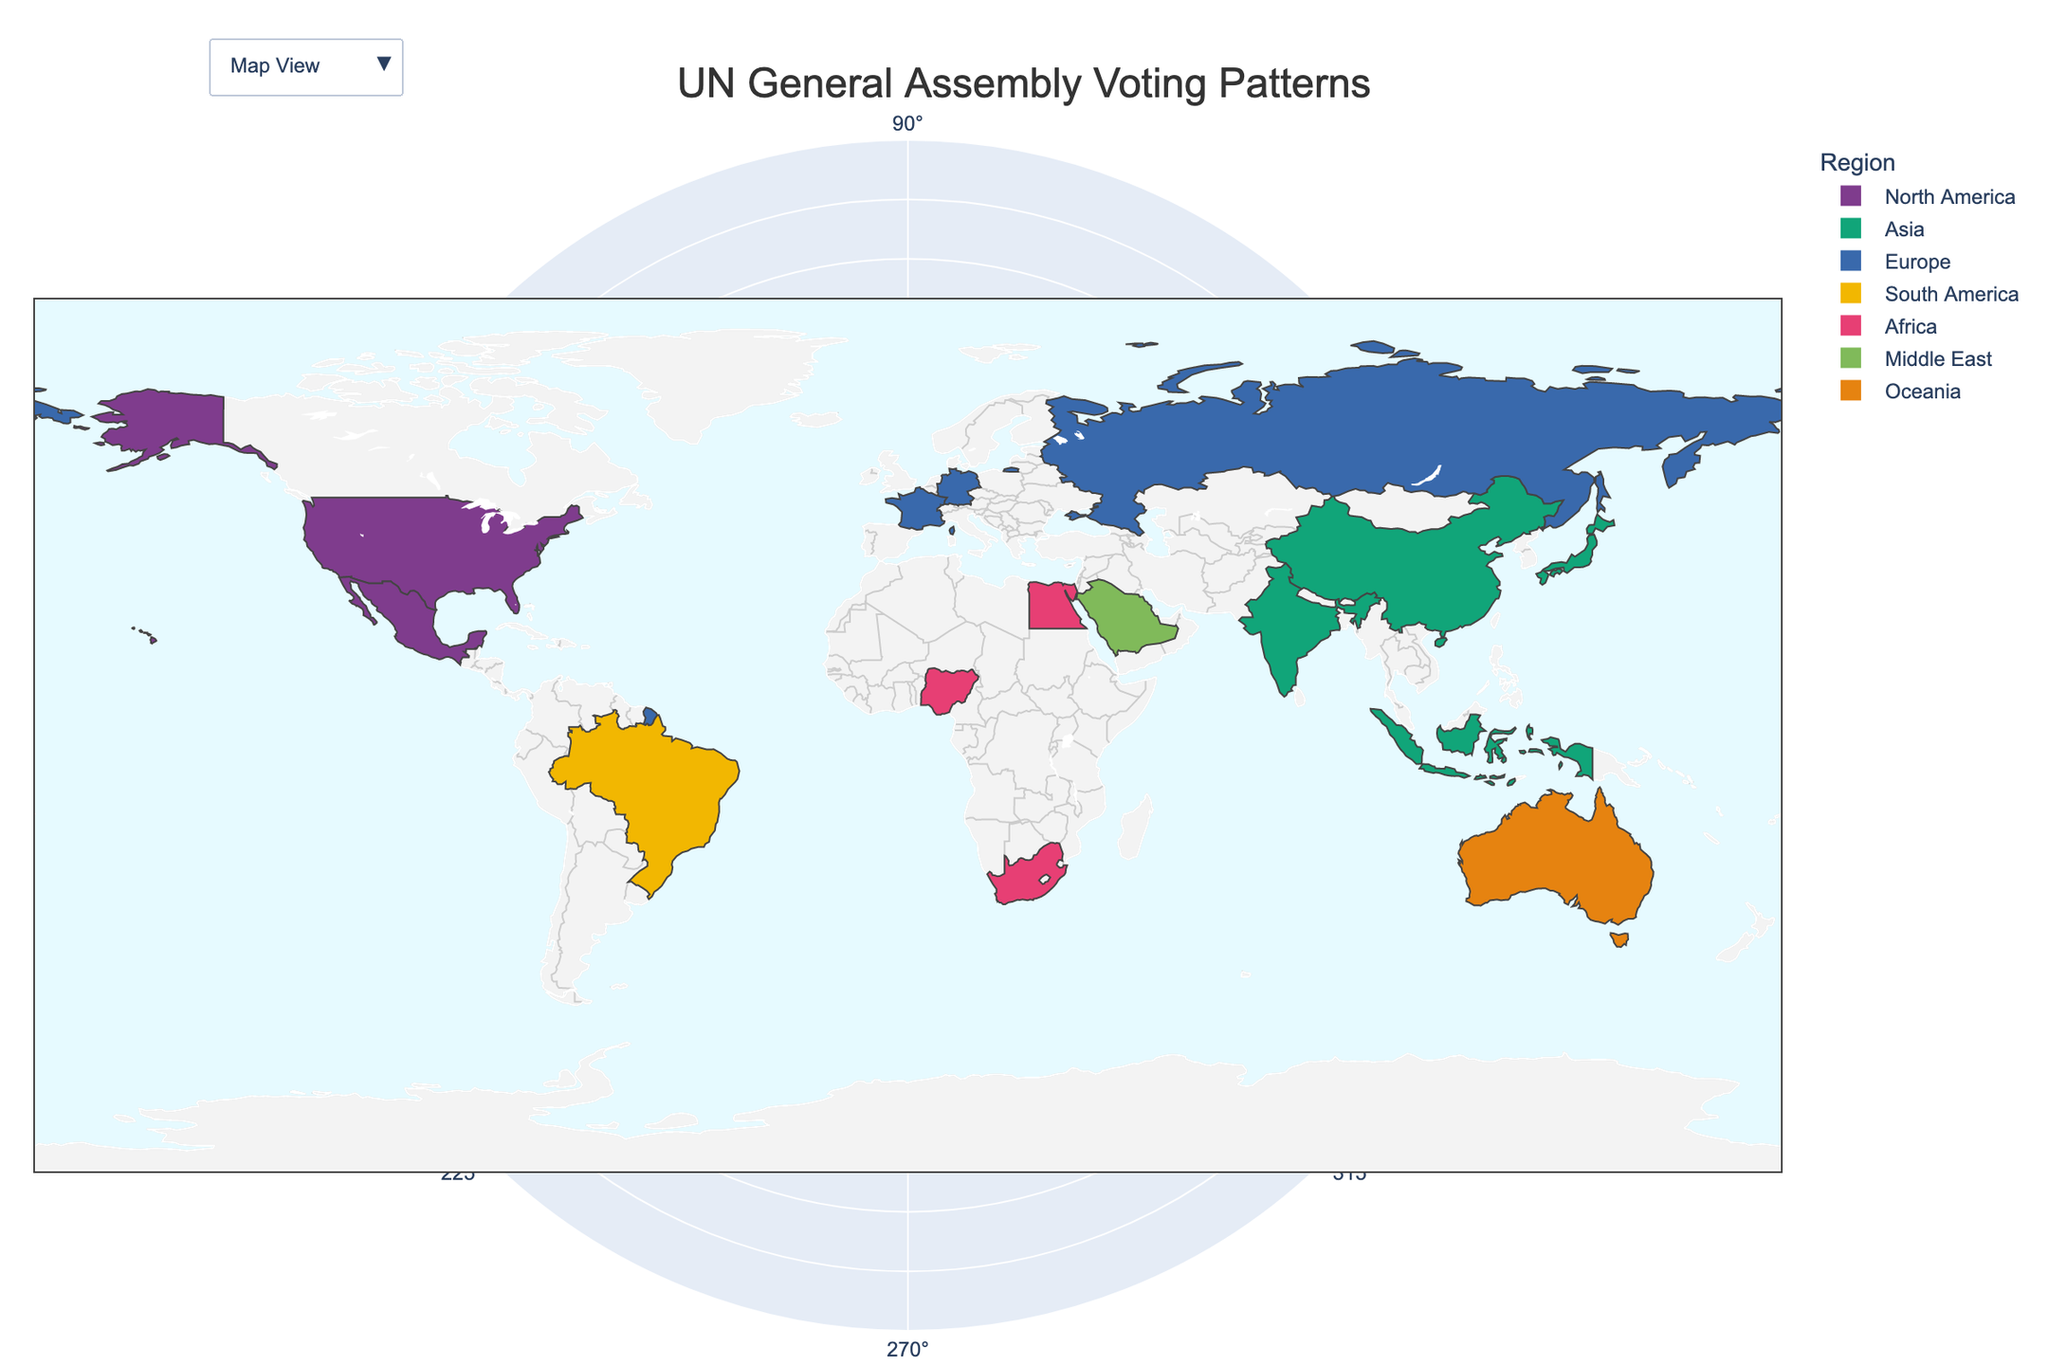How many regions are represented in the map view? The map shows a variety of countries, each colored according to their region. By counting the different colors, we can determine the number of regions present.
Answer: 6 Which country has the highest voting score on Human Rights? To find this, we look at the labels in the radar charts when exploring individual countries' data. The country with the highest value under "Human Rights" will be identified.
Answer: Germany How do the voting patterns on Economic Development compare between Nigeria and Brazil? By examining the radar charts for both Nigeria and Brazil, compare the values for "Economic Development." Nigeria has a score of 75, while Brazil has a score of 80.
Answer: Brazil scores higher What is the average voting score on Climate Change across all regions? Sum the voting scores for Climate Change for all countries and then divide by the number of countries (15). The total sum is 1150. Dividing by the number of countries gives the average: 1150 / 15 = 76.7.
Answer: 76.7 Which region has the most variation in voting patterns across the key issues? Analyze the radar charts for countries within each region, look for the region where the gap between the highest and lowest scores is most significant. The sum and spread of scores can aid in identifying this.
Answer: Asia How does France's voting on Nuclear Non-Proliferation compare to that of Russia? Check the radar chart for France and Russia. France has a score of 90, and Russia has a score of 70 for Nuclear Non-Proliferation.
Answer: France has a higher score Which two countries have the closest voting patterns in Climate Change and Economic Development? Look for countries whose radar charts have similar values for "Climate Change" and "Economic Development." Japan and Germany both have high, close values in these categories (90 and 80 for Japan, 90 and 75 for Germany).
Answer: Japan and Germany Which country in the Middle East has been represented, and what is its voting pattern on Peacekeeping? By looking at the regional colors, identify the country in the Middle East. Then, refer to the radar chart to find the value for Peacekeeping. Saudi Arabia is the country from the Middle East, with a Peacekeeping score of 55.
Answer: Saudi Arabia, score is 55 Which European country has the lowest support for Human Rights resolution? Examine the radar charts of European countries, specifically checking the scores for Human Rights. Russia has the lowest score in this category at 25.
Answer: Russia 